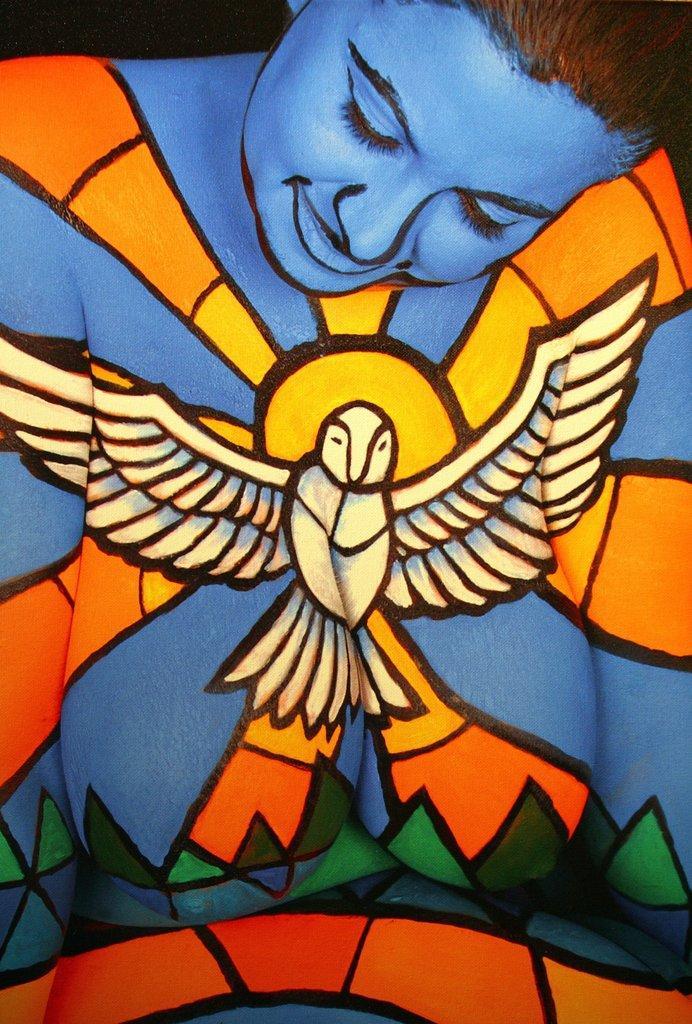Could you give a brief overview of what you see in this image? This is a painting. In this painting, we can see there is a woman in a dress, smiling. And the background is dark in color. 